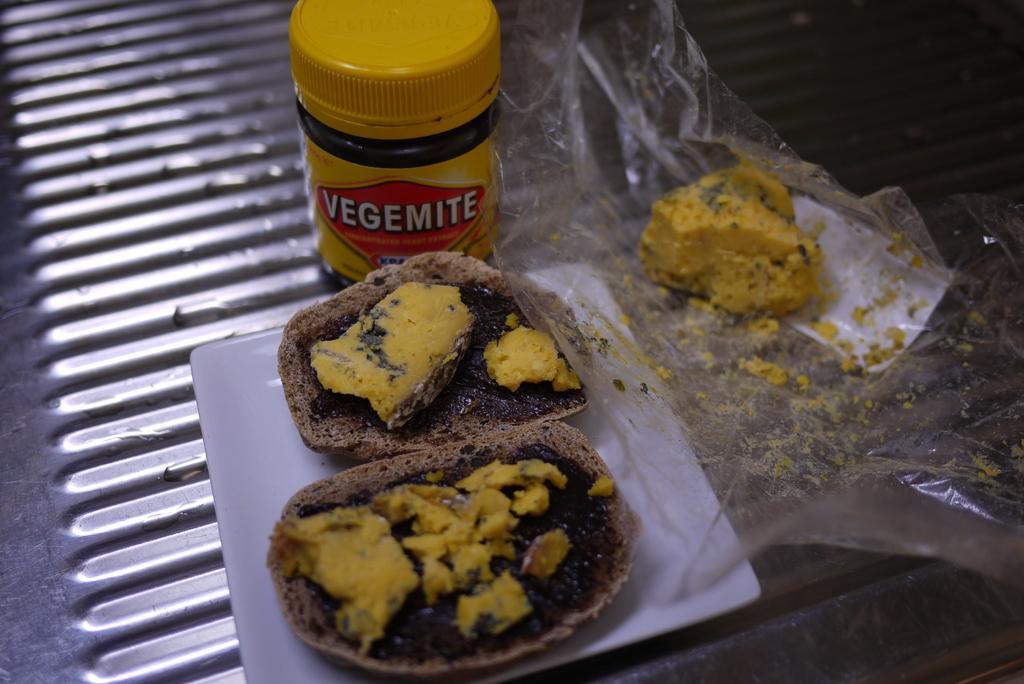In one or two sentences, can you explain what this image depicts? In the foreground of this image, on a platter, there is a chocolate bread on which a cream and cheese on it. On the right, there is a piece of cheese on a cover. On the top, there is a small bottle on the steel surface. 